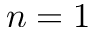Convert formula to latex. <formula><loc_0><loc_0><loc_500><loc_500>n = 1</formula> 